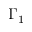<formula> <loc_0><loc_0><loc_500><loc_500>\Gamma _ { 1 }</formula> 